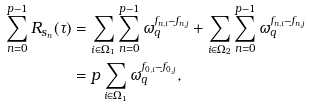Convert formula to latex. <formula><loc_0><loc_0><loc_500><loc_500>\sum _ { n = 0 } ^ { p - 1 } R _ { s _ { n } } ( \tau ) & = \sum _ { i \in \Omega _ { 1 } } \sum _ { n = 0 } ^ { p - 1 } \omega _ { q } ^ { f _ { n , i } - f _ { n , j } } + \sum _ { i \in \Omega _ { 2 } } \sum _ { n = 0 } ^ { p - 1 } \omega _ { q } ^ { f _ { n , i } - f _ { n , j } } \\ & = p \sum _ { i \in \Omega _ { 1 } } \omega _ { q } ^ { f _ { 0 , i } - f _ { 0 , j } } ,</formula> 